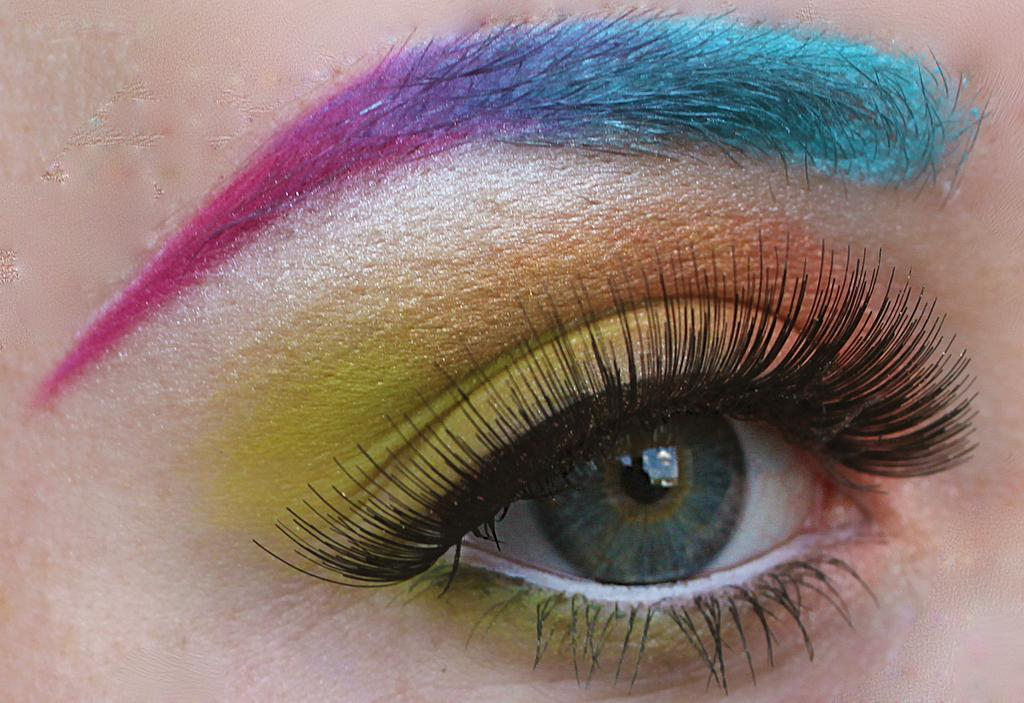What is the main subject of the image? The main subject of the image is a human eye. Are there any artistic elements applied to the eye? Yes, the eye has color painting. What other parts of the eye have color? There is color on the eyebrow and the upper eyelid. What type of desk is visible in the image? There is no desk present in the image; it features a human eye with color painting. What is the duration of the voyage depicted in the image? There is no voyage depicted in the image; it features a human eye with color painting. 